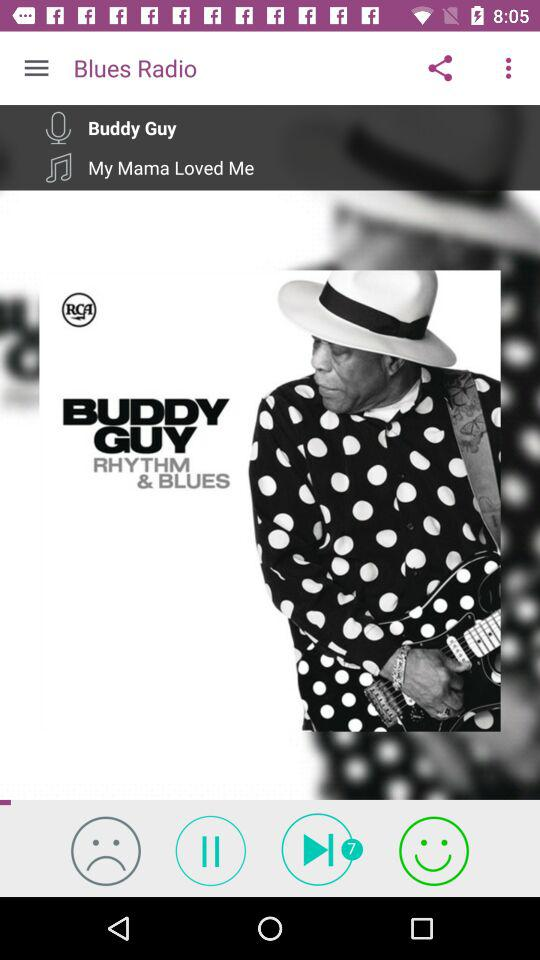What is the singer's name? The singer's name is Buddy Guy. 